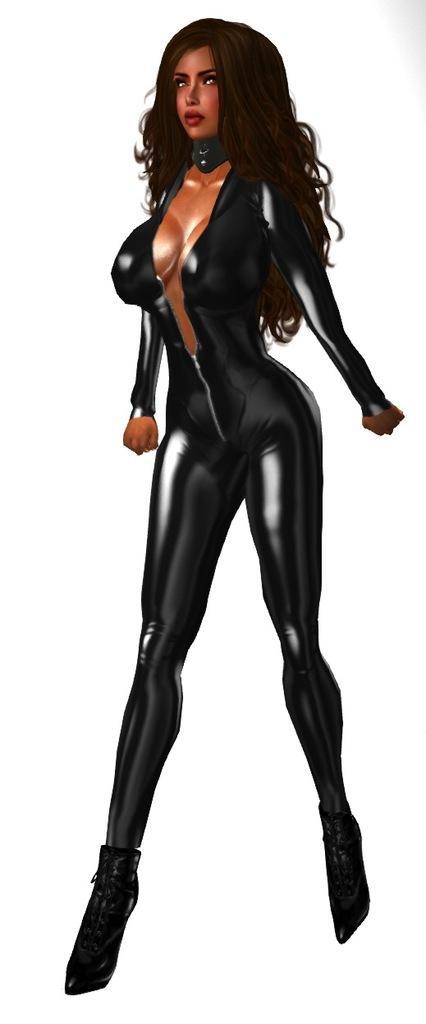How would you summarize this image in a sentence or two? In the image we can see an animated picture of a woman standing, wearing clothes and the background is white. 